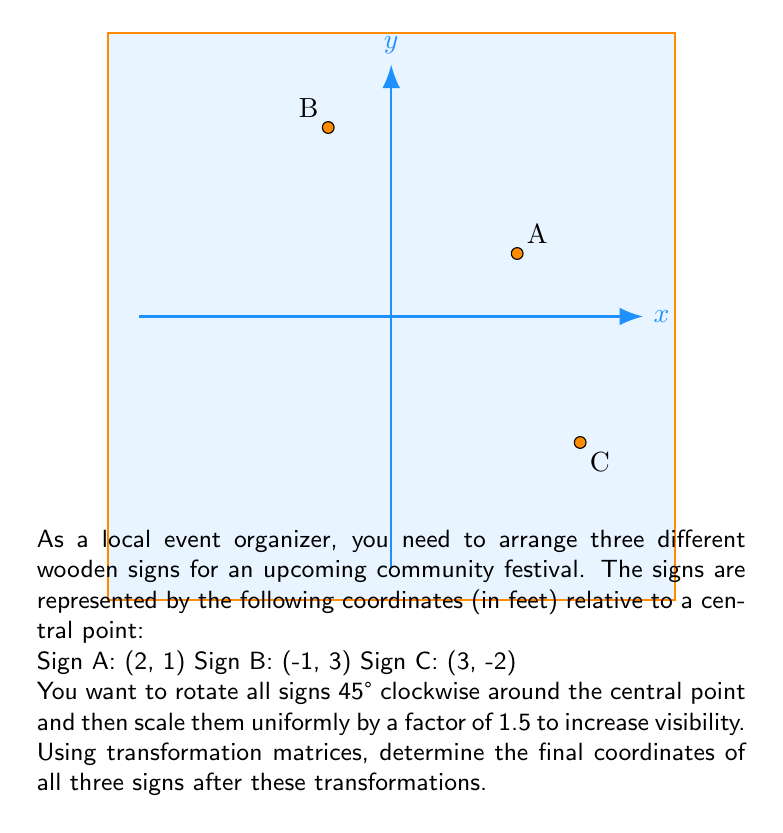What is the answer to this math problem? Let's approach this problem step-by-step using transformation matrices:

1) First, we need to create a matrix containing the initial coordinates of the signs:

   $$P = \begin{bmatrix}
   2 & -1 & 3 \\
   1 & 3 & -2
   \end{bmatrix}$$

2) The rotation matrix for a 45° clockwise rotation is:

   $$R = \begin{bmatrix}
   \cos(-45°) & -\sin(-45°) \\
   \sin(-45°) & \cos(-45°)
   \end{bmatrix} = \begin{bmatrix}
   \frac{\sqrt{2}}{2} & \frac{\sqrt{2}}{2} \\
   -\frac{\sqrt{2}}{2} & \frac{\sqrt{2}}{2}
   \end{bmatrix}$$

3) The scaling matrix for a uniform scaling by 1.5 is:

   $$S = \begin{bmatrix}
   1.5 & 0 \\
   0 & 1.5
   \end{bmatrix}$$

4) We can combine these transformations into a single matrix T:

   $$T = S \cdot R = \begin{bmatrix}
   1.5 & 0 \\
   0 & 1.5
   \end{bmatrix} \cdot \begin{bmatrix}
   \frac{\sqrt{2}}{2} & \frac{\sqrt{2}}{2} \\
   -\frac{\sqrt{2}}{2} & \frac{\sqrt{2}}{2}
   \end{bmatrix} = \begin{bmatrix}
   \frac{3\sqrt{2}}{4} & \frac{3\sqrt{2}}{4} \\
   -\frac{3\sqrt{2}}{4} & \frac{3\sqrt{2}}{4}
   \end{bmatrix}$$

5) Now, we can apply this transformation to our initial coordinates:

   $$P_{final} = T \cdot P = \begin{bmatrix}
   \frac{3\sqrt{2}}{4} & \frac{3\sqrt{2}}{4} \\
   -\frac{3\sqrt{2}}{4} & \frac{3\sqrt{2}}{4}
   \end{bmatrix} \cdot \begin{bmatrix}
   2 & -1 & 3 \\
   1 & 3 & -2
   \end{bmatrix}$$

6) Calculating this matrix multiplication:

   $$P_{final} = \begin{bmatrix}
   \frac{9\sqrt{2}}{4} & \frac{3\sqrt{2}}{2} & \frac{3\sqrt{2}}{4} \\
   -\frac{3\sqrt{2}}{4} & \frac{3\sqrt{2}}{2} & -\frac{15\sqrt{2}}{4}
   \end{bmatrix}$$

7) Converting to decimal form (rounded to two decimal places):

   $$P_{final} \approx \begin{bmatrix}
   3.18 & 2.12 & 1.06 \\
   -1.06 & 2.12 & -5.30
   \end{bmatrix}$$

Therefore, the final coordinates of the signs are:
Sign A: (3.18, -1.06)
Sign B: (2.12, 2.12)
Sign C: (1.06, -5.30)
Answer: A: (3.18, -1.06), B: (2.12, 2.12), C: (1.06, -5.30) 